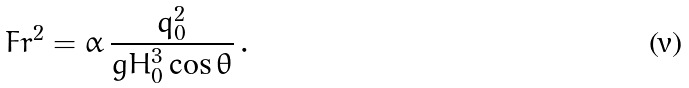Convert formula to latex. <formula><loc_0><loc_0><loc_500><loc_500>\ F r ^ { 2 } = \alpha \, \frac { q _ { 0 } ^ { 2 } } { g H _ { 0 } ^ { 3 } \cos \theta } \, .</formula> 